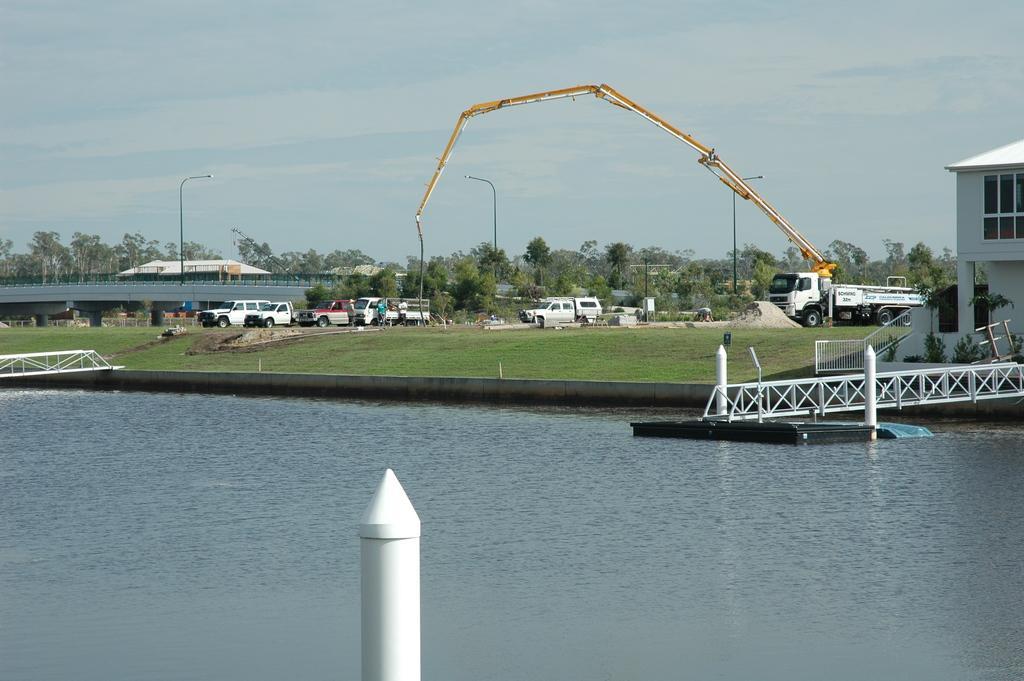Describe this image in one or two sentences. In this image there are two small bridges over the water and a few pillars in the water, few vehicles on the road, a crane on of the vehicles, few trees, buildings, street lights, a bridge over the road and the sky. 